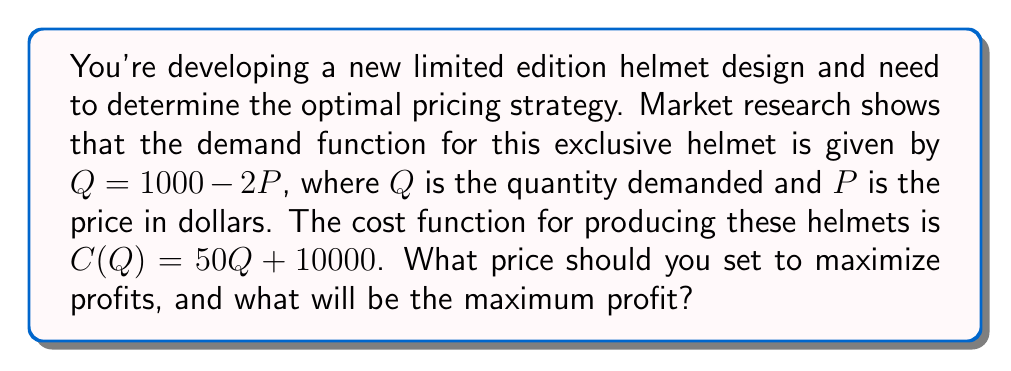Solve this math problem. To solve this optimization problem, we'll follow these steps:

1) First, let's define the profit function. Profit is revenue minus cost:
   $\Pi(Q) = R(Q) - C(Q)$

2) Revenue is price times quantity: $R(Q) = P \cdot Q$
   We need to express P in terms of Q using the demand function:
   $Q = 1000 - 2P$
   $P = 500 - \frac{1}{2}Q$

3) Now we can write the profit function in terms of Q:
   $\Pi(Q) = (500 - \frac{1}{2}Q) \cdot Q - (50Q + 10000)$
   $\Pi(Q) = 500Q - \frac{1}{2}Q^2 - 50Q - 10000$
   $\Pi(Q) = 450Q - \frac{1}{2}Q^2 - 10000$

4) To find the maximum profit, we differentiate $\Pi(Q)$ with respect to Q and set it to zero:
   $\frac{d\Pi}{dQ} = 450 - Q = 0$
   $Q = 450$

5) We can verify this is a maximum by checking the second derivative is negative:
   $\frac{d^2\Pi}{dQ^2} = -1 < 0$

6) Now we know the optimal quantity is 450. We can find the optimal price using the demand function:
   $450 = 1000 - 2P$
   $P = 275$

7) Finally, we can calculate the maximum profit by substituting Q = 450 into our profit function:
   $\Pi(450) = 450(450) - \frac{1}{2}(450)^2 - 10000$
   $= 202500 - 101250 - 10000$
   $= 91250$
Answer: The optimal price is $275, and the maximum profit is $91,250. 